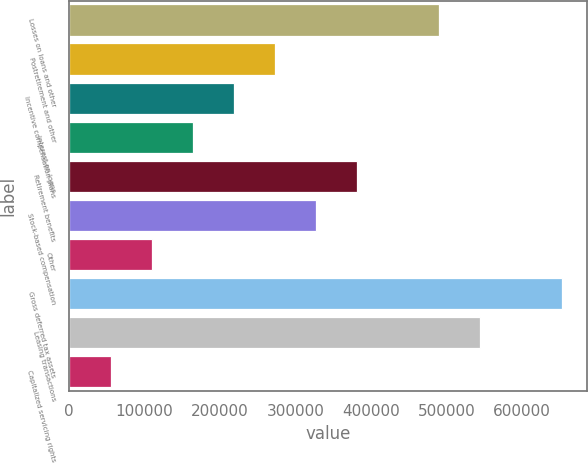Convert chart. <chart><loc_0><loc_0><loc_500><loc_500><bar_chart><fcel>Losses on loans and other<fcel>Postretirement and other<fcel>Incentive compensation plans<fcel>Interest on loans<fcel>Retirement benefits<fcel>Stock-based compensation<fcel>Other<fcel>Gross deferred tax assets<fcel>Leasing transactions<fcel>Capitalized servicing rights<nl><fcel>490266<fcel>272522<fcel>218086<fcel>163650<fcel>381394<fcel>326958<fcel>109214<fcel>653574<fcel>544702<fcel>54778<nl></chart> 